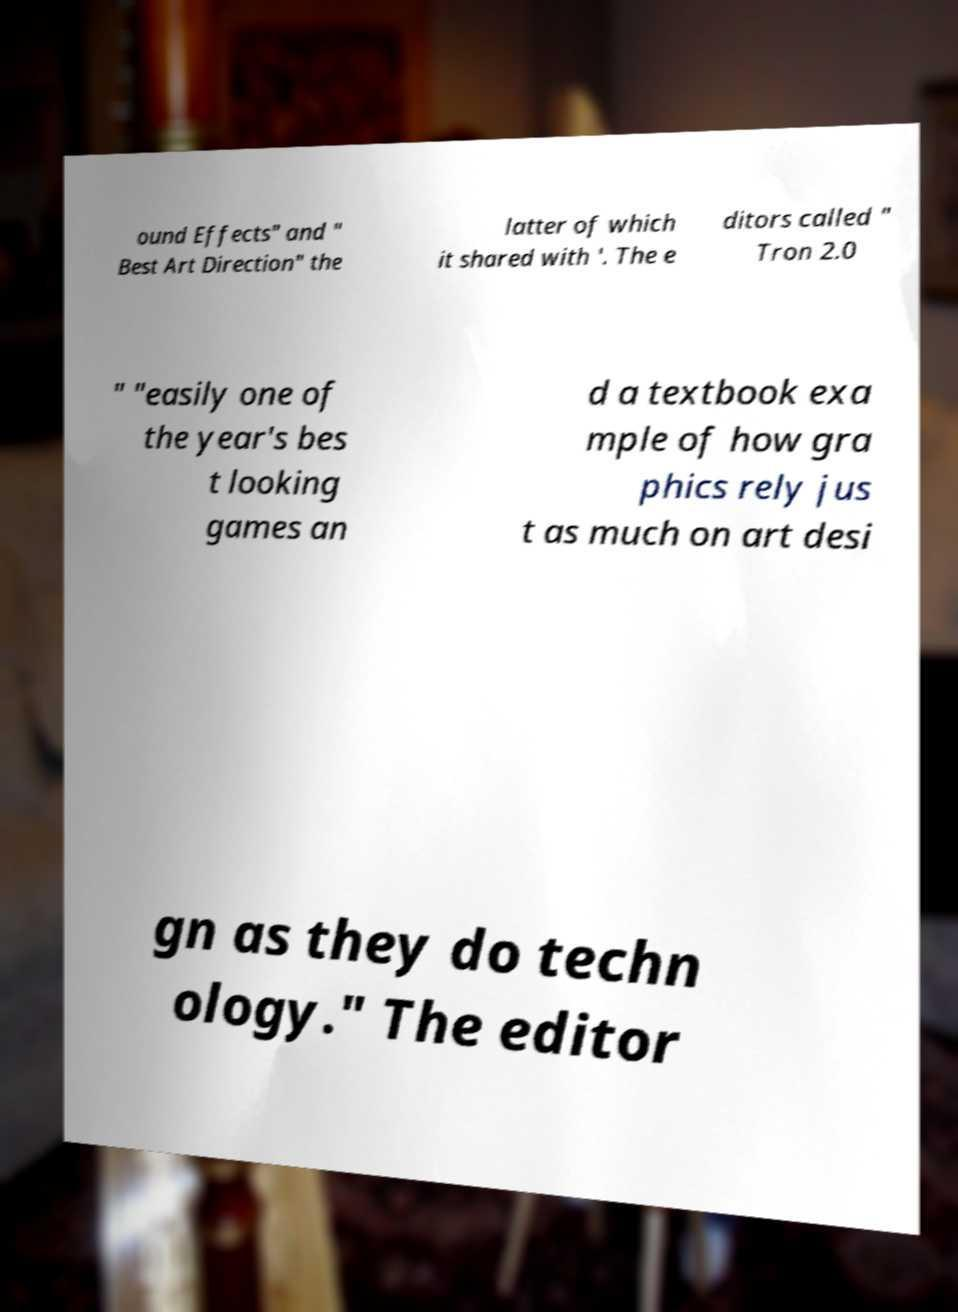What messages or text are displayed in this image? I need them in a readable, typed format. ound Effects" and " Best Art Direction" the latter of which it shared with '. The e ditors called " Tron 2.0 " "easily one of the year's bes t looking games an d a textbook exa mple of how gra phics rely jus t as much on art desi gn as they do techn ology." The editor 